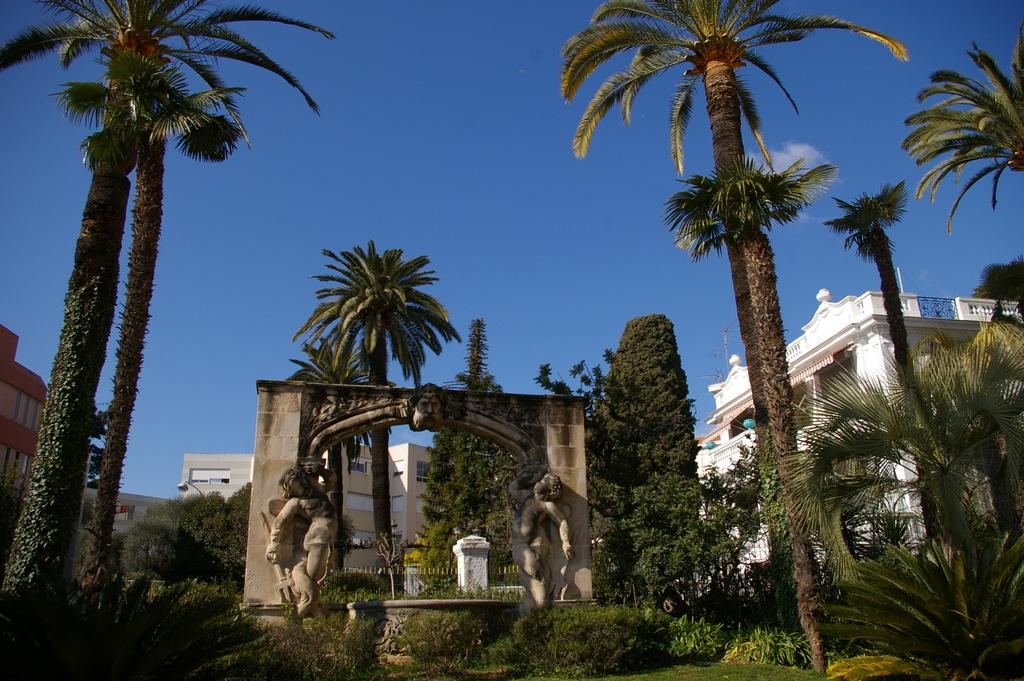What type of vegetation can be seen in the image? There are plants, trees, and grass visible in the image. What architectural feature is present in the image? There is an arch with sculptures in the image. What structures can be seen in the background of the image? There are buildings, trees, a fence, railings, and a light pole visible in the background of the image. What part of the natural environment is visible in the image? The sky is visible in the background of the image. Where is the faucet located in the image? There is no faucet present in the image. What scientific theory is being discussed in the image? There is no discussion of a scientific theory in the image. 